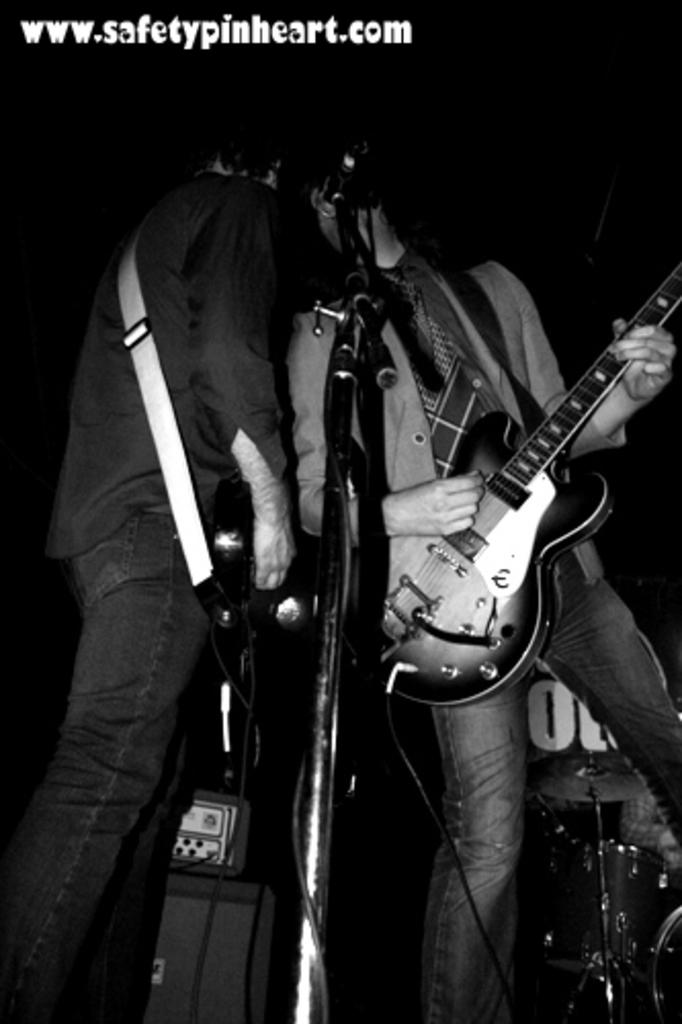What is the color scheme of the image? The image is black and white. How many people are in the image? There are two persons in the image. What are the two persons doing in the image? The two persons are playing guitar. What object is present in the image that is commonly used for amplifying sound? There is a microphone (mike) in the image. What other objects can be seen in the image related to music? There are musical instruments in the image. Can you tell me how many times the camera has been turned on and off during the performance in the image? There is no camera present in the image, so it is not possible to determine how many times it has been turned on and off. 